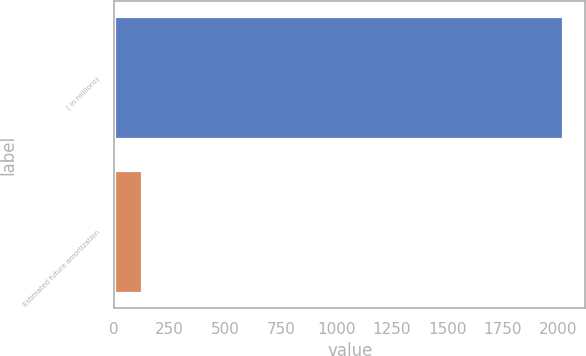<chart> <loc_0><loc_0><loc_500><loc_500><bar_chart><fcel>( in millions)<fcel>Estimated future amortization<nl><fcel>2019<fcel>125<nl></chart> 